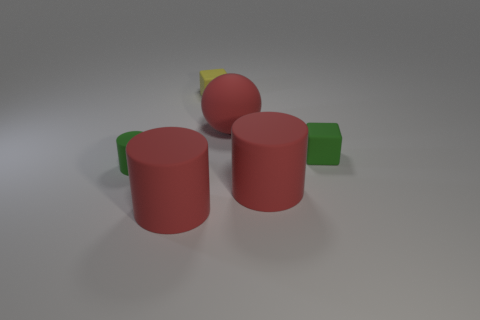The object that is the same color as the small rubber cylinder is what size?
Offer a terse response. Small. Is there any other thing that has the same size as the yellow object?
Your response must be concise. Yes. How many matte things are there?
Keep it short and to the point. 6. Are there any large shiny spheres of the same color as the large rubber sphere?
Offer a terse response. No. The small block that is in front of the matte cube that is left of the green object right of the tiny yellow block is what color?
Provide a succinct answer. Green. Are the yellow object and the big cylinder right of the yellow matte cube made of the same material?
Make the answer very short. Yes. What is the ball made of?
Offer a terse response. Rubber. There is a block that is the same color as the tiny rubber cylinder; what is its material?
Provide a short and direct response. Rubber. What number of other things are made of the same material as the sphere?
Give a very brief answer. 5. There is a thing that is to the right of the big red ball and behind the tiny green matte cylinder; what shape is it?
Your answer should be compact. Cube. 